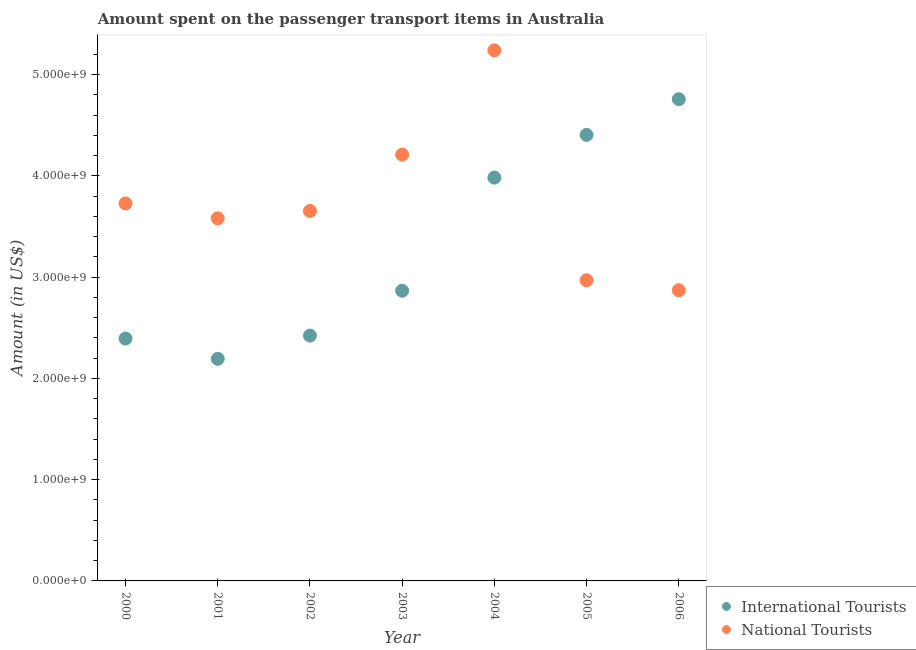Is the number of dotlines equal to the number of legend labels?
Your answer should be very brief. Yes. What is the amount spent on transport items of international tourists in 2002?
Provide a succinct answer. 2.42e+09. Across all years, what is the maximum amount spent on transport items of national tourists?
Offer a very short reply. 5.24e+09. Across all years, what is the minimum amount spent on transport items of national tourists?
Your answer should be compact. 2.87e+09. In which year was the amount spent on transport items of national tourists maximum?
Keep it short and to the point. 2004. What is the total amount spent on transport items of national tourists in the graph?
Ensure brevity in your answer.  2.62e+1. What is the difference between the amount spent on transport items of national tourists in 2002 and that in 2003?
Ensure brevity in your answer.  -5.56e+08. What is the difference between the amount spent on transport items of national tourists in 2000 and the amount spent on transport items of international tourists in 2004?
Offer a very short reply. -2.55e+08. What is the average amount spent on transport items of national tourists per year?
Offer a terse response. 3.75e+09. In the year 2000, what is the difference between the amount spent on transport items of international tourists and amount spent on transport items of national tourists?
Offer a very short reply. -1.33e+09. In how many years, is the amount spent on transport items of national tourists greater than 2600000000 US$?
Provide a short and direct response. 7. What is the ratio of the amount spent on transport items of national tourists in 2000 to that in 2005?
Offer a very short reply. 1.26. Is the amount spent on transport items of national tourists in 2001 less than that in 2005?
Provide a short and direct response. No. Is the difference between the amount spent on transport items of international tourists in 2002 and 2004 greater than the difference between the amount spent on transport items of national tourists in 2002 and 2004?
Offer a very short reply. Yes. What is the difference between the highest and the second highest amount spent on transport items of national tourists?
Ensure brevity in your answer.  1.03e+09. What is the difference between the highest and the lowest amount spent on transport items of national tourists?
Provide a short and direct response. 2.37e+09. In how many years, is the amount spent on transport items of national tourists greater than the average amount spent on transport items of national tourists taken over all years?
Offer a very short reply. 2. Is the sum of the amount spent on transport items of international tourists in 2000 and 2002 greater than the maximum amount spent on transport items of national tourists across all years?
Your answer should be very brief. No. Does the graph contain grids?
Give a very brief answer. No. What is the title of the graph?
Offer a terse response. Amount spent on the passenger transport items in Australia. What is the label or title of the X-axis?
Make the answer very short. Year. What is the label or title of the Y-axis?
Your answer should be very brief. Amount (in US$). What is the Amount (in US$) of International Tourists in 2000?
Your answer should be compact. 2.39e+09. What is the Amount (in US$) of National Tourists in 2000?
Provide a short and direct response. 3.73e+09. What is the Amount (in US$) in International Tourists in 2001?
Ensure brevity in your answer.  2.19e+09. What is the Amount (in US$) of National Tourists in 2001?
Keep it short and to the point. 3.58e+09. What is the Amount (in US$) in International Tourists in 2002?
Ensure brevity in your answer.  2.42e+09. What is the Amount (in US$) of National Tourists in 2002?
Make the answer very short. 3.65e+09. What is the Amount (in US$) of International Tourists in 2003?
Ensure brevity in your answer.  2.86e+09. What is the Amount (in US$) of National Tourists in 2003?
Provide a short and direct response. 4.21e+09. What is the Amount (in US$) of International Tourists in 2004?
Your answer should be very brief. 3.98e+09. What is the Amount (in US$) in National Tourists in 2004?
Your answer should be compact. 5.24e+09. What is the Amount (in US$) in International Tourists in 2005?
Provide a short and direct response. 4.40e+09. What is the Amount (in US$) of National Tourists in 2005?
Offer a very short reply. 2.97e+09. What is the Amount (in US$) of International Tourists in 2006?
Your response must be concise. 4.76e+09. What is the Amount (in US$) in National Tourists in 2006?
Offer a terse response. 2.87e+09. Across all years, what is the maximum Amount (in US$) in International Tourists?
Make the answer very short. 4.76e+09. Across all years, what is the maximum Amount (in US$) of National Tourists?
Keep it short and to the point. 5.24e+09. Across all years, what is the minimum Amount (in US$) in International Tourists?
Offer a terse response. 2.19e+09. Across all years, what is the minimum Amount (in US$) of National Tourists?
Provide a succinct answer. 2.87e+09. What is the total Amount (in US$) in International Tourists in the graph?
Your answer should be very brief. 2.30e+1. What is the total Amount (in US$) in National Tourists in the graph?
Give a very brief answer. 2.62e+1. What is the difference between the Amount (in US$) of International Tourists in 2000 and that in 2001?
Keep it short and to the point. 2.00e+08. What is the difference between the Amount (in US$) of National Tourists in 2000 and that in 2001?
Ensure brevity in your answer.  1.47e+08. What is the difference between the Amount (in US$) in International Tourists in 2000 and that in 2002?
Your answer should be compact. -2.90e+07. What is the difference between the Amount (in US$) of National Tourists in 2000 and that in 2002?
Offer a very short reply. 7.40e+07. What is the difference between the Amount (in US$) of International Tourists in 2000 and that in 2003?
Your answer should be compact. -4.72e+08. What is the difference between the Amount (in US$) in National Tourists in 2000 and that in 2003?
Provide a succinct answer. -4.82e+08. What is the difference between the Amount (in US$) of International Tourists in 2000 and that in 2004?
Make the answer very short. -1.59e+09. What is the difference between the Amount (in US$) of National Tourists in 2000 and that in 2004?
Your answer should be compact. -1.51e+09. What is the difference between the Amount (in US$) of International Tourists in 2000 and that in 2005?
Your answer should be very brief. -2.01e+09. What is the difference between the Amount (in US$) in National Tourists in 2000 and that in 2005?
Keep it short and to the point. 7.58e+08. What is the difference between the Amount (in US$) in International Tourists in 2000 and that in 2006?
Your answer should be compact. -2.36e+09. What is the difference between the Amount (in US$) in National Tourists in 2000 and that in 2006?
Ensure brevity in your answer.  8.57e+08. What is the difference between the Amount (in US$) in International Tourists in 2001 and that in 2002?
Provide a succinct answer. -2.29e+08. What is the difference between the Amount (in US$) in National Tourists in 2001 and that in 2002?
Provide a succinct answer. -7.30e+07. What is the difference between the Amount (in US$) in International Tourists in 2001 and that in 2003?
Your answer should be very brief. -6.72e+08. What is the difference between the Amount (in US$) in National Tourists in 2001 and that in 2003?
Offer a terse response. -6.29e+08. What is the difference between the Amount (in US$) in International Tourists in 2001 and that in 2004?
Your response must be concise. -1.79e+09. What is the difference between the Amount (in US$) of National Tourists in 2001 and that in 2004?
Offer a very short reply. -1.66e+09. What is the difference between the Amount (in US$) in International Tourists in 2001 and that in 2005?
Provide a succinct answer. -2.21e+09. What is the difference between the Amount (in US$) in National Tourists in 2001 and that in 2005?
Ensure brevity in your answer.  6.11e+08. What is the difference between the Amount (in US$) of International Tourists in 2001 and that in 2006?
Provide a short and direct response. -2.56e+09. What is the difference between the Amount (in US$) in National Tourists in 2001 and that in 2006?
Offer a terse response. 7.10e+08. What is the difference between the Amount (in US$) in International Tourists in 2002 and that in 2003?
Your response must be concise. -4.43e+08. What is the difference between the Amount (in US$) of National Tourists in 2002 and that in 2003?
Offer a very short reply. -5.56e+08. What is the difference between the Amount (in US$) of International Tourists in 2002 and that in 2004?
Offer a very short reply. -1.56e+09. What is the difference between the Amount (in US$) in National Tourists in 2002 and that in 2004?
Your answer should be compact. -1.59e+09. What is the difference between the Amount (in US$) of International Tourists in 2002 and that in 2005?
Make the answer very short. -1.98e+09. What is the difference between the Amount (in US$) in National Tourists in 2002 and that in 2005?
Offer a very short reply. 6.84e+08. What is the difference between the Amount (in US$) in International Tourists in 2002 and that in 2006?
Offer a very short reply. -2.33e+09. What is the difference between the Amount (in US$) in National Tourists in 2002 and that in 2006?
Your answer should be compact. 7.83e+08. What is the difference between the Amount (in US$) of International Tourists in 2003 and that in 2004?
Offer a terse response. -1.12e+09. What is the difference between the Amount (in US$) of National Tourists in 2003 and that in 2004?
Keep it short and to the point. -1.03e+09. What is the difference between the Amount (in US$) of International Tourists in 2003 and that in 2005?
Your answer should be very brief. -1.54e+09. What is the difference between the Amount (in US$) of National Tourists in 2003 and that in 2005?
Offer a very short reply. 1.24e+09. What is the difference between the Amount (in US$) of International Tourists in 2003 and that in 2006?
Keep it short and to the point. -1.89e+09. What is the difference between the Amount (in US$) of National Tourists in 2003 and that in 2006?
Keep it short and to the point. 1.34e+09. What is the difference between the Amount (in US$) of International Tourists in 2004 and that in 2005?
Provide a succinct answer. -4.22e+08. What is the difference between the Amount (in US$) in National Tourists in 2004 and that in 2005?
Your answer should be compact. 2.27e+09. What is the difference between the Amount (in US$) of International Tourists in 2004 and that in 2006?
Your response must be concise. -7.74e+08. What is the difference between the Amount (in US$) in National Tourists in 2004 and that in 2006?
Offer a terse response. 2.37e+09. What is the difference between the Amount (in US$) in International Tourists in 2005 and that in 2006?
Your answer should be compact. -3.52e+08. What is the difference between the Amount (in US$) of National Tourists in 2005 and that in 2006?
Your response must be concise. 9.90e+07. What is the difference between the Amount (in US$) of International Tourists in 2000 and the Amount (in US$) of National Tourists in 2001?
Keep it short and to the point. -1.19e+09. What is the difference between the Amount (in US$) in International Tourists in 2000 and the Amount (in US$) in National Tourists in 2002?
Keep it short and to the point. -1.26e+09. What is the difference between the Amount (in US$) of International Tourists in 2000 and the Amount (in US$) of National Tourists in 2003?
Keep it short and to the point. -1.82e+09. What is the difference between the Amount (in US$) in International Tourists in 2000 and the Amount (in US$) in National Tourists in 2004?
Provide a succinct answer. -2.85e+09. What is the difference between the Amount (in US$) in International Tourists in 2000 and the Amount (in US$) in National Tourists in 2005?
Your answer should be very brief. -5.76e+08. What is the difference between the Amount (in US$) in International Tourists in 2000 and the Amount (in US$) in National Tourists in 2006?
Give a very brief answer. -4.77e+08. What is the difference between the Amount (in US$) in International Tourists in 2001 and the Amount (in US$) in National Tourists in 2002?
Your answer should be very brief. -1.46e+09. What is the difference between the Amount (in US$) of International Tourists in 2001 and the Amount (in US$) of National Tourists in 2003?
Offer a very short reply. -2.02e+09. What is the difference between the Amount (in US$) of International Tourists in 2001 and the Amount (in US$) of National Tourists in 2004?
Your response must be concise. -3.05e+09. What is the difference between the Amount (in US$) of International Tourists in 2001 and the Amount (in US$) of National Tourists in 2005?
Provide a succinct answer. -7.76e+08. What is the difference between the Amount (in US$) in International Tourists in 2001 and the Amount (in US$) in National Tourists in 2006?
Give a very brief answer. -6.77e+08. What is the difference between the Amount (in US$) of International Tourists in 2002 and the Amount (in US$) of National Tourists in 2003?
Your answer should be very brief. -1.79e+09. What is the difference between the Amount (in US$) in International Tourists in 2002 and the Amount (in US$) in National Tourists in 2004?
Your answer should be very brief. -2.82e+09. What is the difference between the Amount (in US$) of International Tourists in 2002 and the Amount (in US$) of National Tourists in 2005?
Make the answer very short. -5.47e+08. What is the difference between the Amount (in US$) of International Tourists in 2002 and the Amount (in US$) of National Tourists in 2006?
Keep it short and to the point. -4.48e+08. What is the difference between the Amount (in US$) of International Tourists in 2003 and the Amount (in US$) of National Tourists in 2004?
Provide a short and direct response. -2.37e+09. What is the difference between the Amount (in US$) in International Tourists in 2003 and the Amount (in US$) in National Tourists in 2005?
Your answer should be very brief. -1.04e+08. What is the difference between the Amount (in US$) of International Tourists in 2003 and the Amount (in US$) of National Tourists in 2006?
Your answer should be compact. -5.00e+06. What is the difference between the Amount (in US$) of International Tourists in 2004 and the Amount (in US$) of National Tourists in 2005?
Keep it short and to the point. 1.01e+09. What is the difference between the Amount (in US$) of International Tourists in 2004 and the Amount (in US$) of National Tourists in 2006?
Your answer should be very brief. 1.11e+09. What is the difference between the Amount (in US$) of International Tourists in 2005 and the Amount (in US$) of National Tourists in 2006?
Your answer should be compact. 1.53e+09. What is the average Amount (in US$) in International Tourists per year?
Provide a short and direct response. 3.29e+09. What is the average Amount (in US$) in National Tourists per year?
Your answer should be very brief. 3.75e+09. In the year 2000, what is the difference between the Amount (in US$) in International Tourists and Amount (in US$) in National Tourists?
Ensure brevity in your answer.  -1.33e+09. In the year 2001, what is the difference between the Amount (in US$) of International Tourists and Amount (in US$) of National Tourists?
Offer a very short reply. -1.39e+09. In the year 2002, what is the difference between the Amount (in US$) in International Tourists and Amount (in US$) in National Tourists?
Offer a very short reply. -1.23e+09. In the year 2003, what is the difference between the Amount (in US$) of International Tourists and Amount (in US$) of National Tourists?
Provide a short and direct response. -1.34e+09. In the year 2004, what is the difference between the Amount (in US$) in International Tourists and Amount (in US$) in National Tourists?
Ensure brevity in your answer.  -1.26e+09. In the year 2005, what is the difference between the Amount (in US$) in International Tourists and Amount (in US$) in National Tourists?
Make the answer very short. 1.44e+09. In the year 2006, what is the difference between the Amount (in US$) in International Tourists and Amount (in US$) in National Tourists?
Your answer should be very brief. 1.89e+09. What is the ratio of the Amount (in US$) in International Tourists in 2000 to that in 2001?
Provide a short and direct response. 1.09. What is the ratio of the Amount (in US$) in National Tourists in 2000 to that in 2001?
Provide a short and direct response. 1.04. What is the ratio of the Amount (in US$) in International Tourists in 2000 to that in 2002?
Your answer should be very brief. 0.99. What is the ratio of the Amount (in US$) of National Tourists in 2000 to that in 2002?
Provide a succinct answer. 1.02. What is the ratio of the Amount (in US$) in International Tourists in 2000 to that in 2003?
Keep it short and to the point. 0.84. What is the ratio of the Amount (in US$) of National Tourists in 2000 to that in 2003?
Ensure brevity in your answer.  0.89. What is the ratio of the Amount (in US$) of International Tourists in 2000 to that in 2004?
Give a very brief answer. 0.6. What is the ratio of the Amount (in US$) in National Tourists in 2000 to that in 2004?
Ensure brevity in your answer.  0.71. What is the ratio of the Amount (in US$) in International Tourists in 2000 to that in 2005?
Provide a succinct answer. 0.54. What is the ratio of the Amount (in US$) of National Tourists in 2000 to that in 2005?
Keep it short and to the point. 1.26. What is the ratio of the Amount (in US$) in International Tourists in 2000 to that in 2006?
Your answer should be compact. 0.5. What is the ratio of the Amount (in US$) of National Tourists in 2000 to that in 2006?
Provide a succinct answer. 1.3. What is the ratio of the Amount (in US$) in International Tourists in 2001 to that in 2002?
Keep it short and to the point. 0.91. What is the ratio of the Amount (in US$) in National Tourists in 2001 to that in 2002?
Provide a short and direct response. 0.98. What is the ratio of the Amount (in US$) in International Tourists in 2001 to that in 2003?
Provide a short and direct response. 0.77. What is the ratio of the Amount (in US$) in National Tourists in 2001 to that in 2003?
Ensure brevity in your answer.  0.85. What is the ratio of the Amount (in US$) of International Tourists in 2001 to that in 2004?
Make the answer very short. 0.55. What is the ratio of the Amount (in US$) of National Tourists in 2001 to that in 2004?
Your response must be concise. 0.68. What is the ratio of the Amount (in US$) in International Tourists in 2001 to that in 2005?
Your answer should be compact. 0.5. What is the ratio of the Amount (in US$) in National Tourists in 2001 to that in 2005?
Your answer should be compact. 1.21. What is the ratio of the Amount (in US$) of International Tourists in 2001 to that in 2006?
Provide a short and direct response. 0.46. What is the ratio of the Amount (in US$) of National Tourists in 2001 to that in 2006?
Give a very brief answer. 1.25. What is the ratio of the Amount (in US$) in International Tourists in 2002 to that in 2003?
Give a very brief answer. 0.85. What is the ratio of the Amount (in US$) in National Tourists in 2002 to that in 2003?
Your response must be concise. 0.87. What is the ratio of the Amount (in US$) of International Tourists in 2002 to that in 2004?
Give a very brief answer. 0.61. What is the ratio of the Amount (in US$) of National Tourists in 2002 to that in 2004?
Your response must be concise. 0.7. What is the ratio of the Amount (in US$) of International Tourists in 2002 to that in 2005?
Give a very brief answer. 0.55. What is the ratio of the Amount (in US$) of National Tourists in 2002 to that in 2005?
Give a very brief answer. 1.23. What is the ratio of the Amount (in US$) in International Tourists in 2002 to that in 2006?
Provide a short and direct response. 0.51. What is the ratio of the Amount (in US$) of National Tourists in 2002 to that in 2006?
Offer a very short reply. 1.27. What is the ratio of the Amount (in US$) of International Tourists in 2003 to that in 2004?
Provide a succinct answer. 0.72. What is the ratio of the Amount (in US$) in National Tourists in 2003 to that in 2004?
Offer a terse response. 0.8. What is the ratio of the Amount (in US$) of International Tourists in 2003 to that in 2005?
Provide a succinct answer. 0.65. What is the ratio of the Amount (in US$) in National Tourists in 2003 to that in 2005?
Keep it short and to the point. 1.42. What is the ratio of the Amount (in US$) in International Tourists in 2003 to that in 2006?
Your answer should be compact. 0.6. What is the ratio of the Amount (in US$) in National Tourists in 2003 to that in 2006?
Ensure brevity in your answer.  1.47. What is the ratio of the Amount (in US$) of International Tourists in 2004 to that in 2005?
Offer a terse response. 0.9. What is the ratio of the Amount (in US$) in National Tourists in 2004 to that in 2005?
Provide a succinct answer. 1.76. What is the ratio of the Amount (in US$) of International Tourists in 2004 to that in 2006?
Provide a succinct answer. 0.84. What is the ratio of the Amount (in US$) in National Tourists in 2004 to that in 2006?
Give a very brief answer. 1.83. What is the ratio of the Amount (in US$) in International Tourists in 2005 to that in 2006?
Your response must be concise. 0.93. What is the ratio of the Amount (in US$) of National Tourists in 2005 to that in 2006?
Provide a short and direct response. 1.03. What is the difference between the highest and the second highest Amount (in US$) in International Tourists?
Keep it short and to the point. 3.52e+08. What is the difference between the highest and the second highest Amount (in US$) of National Tourists?
Your answer should be very brief. 1.03e+09. What is the difference between the highest and the lowest Amount (in US$) of International Tourists?
Ensure brevity in your answer.  2.56e+09. What is the difference between the highest and the lowest Amount (in US$) in National Tourists?
Offer a very short reply. 2.37e+09. 